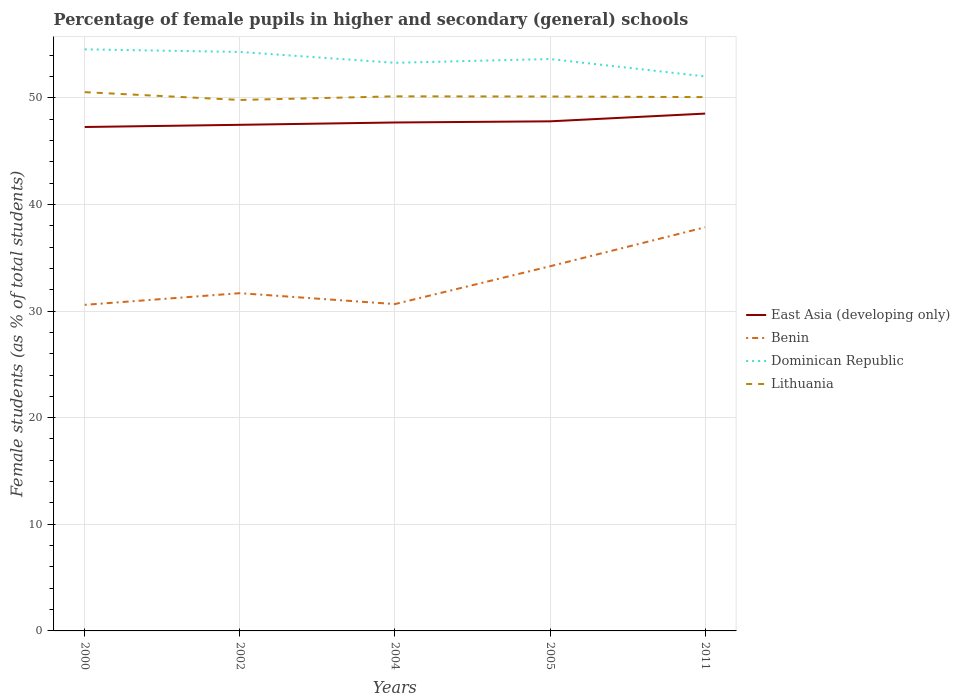Is the number of lines equal to the number of legend labels?
Offer a very short reply. Yes. Across all years, what is the maximum percentage of female pupils in higher and secondary schools in Benin?
Your response must be concise. 30.58. In which year was the percentage of female pupils in higher and secondary schools in Lithuania maximum?
Your answer should be very brief. 2002. What is the total percentage of female pupils in higher and secondary schools in Dominican Republic in the graph?
Provide a short and direct response. 1.63. What is the difference between the highest and the second highest percentage of female pupils in higher and secondary schools in Lithuania?
Your answer should be very brief. 0.73. How many years are there in the graph?
Give a very brief answer. 5. What is the difference between two consecutive major ticks on the Y-axis?
Your answer should be very brief. 10. Are the values on the major ticks of Y-axis written in scientific E-notation?
Offer a terse response. No. Does the graph contain any zero values?
Offer a very short reply. No. Where does the legend appear in the graph?
Provide a short and direct response. Center right. How are the legend labels stacked?
Provide a succinct answer. Vertical. What is the title of the graph?
Provide a short and direct response. Percentage of female pupils in higher and secondary (general) schools. Does "Saudi Arabia" appear as one of the legend labels in the graph?
Offer a terse response. No. What is the label or title of the Y-axis?
Provide a succinct answer. Female students (as % of total students). What is the Female students (as % of total students) of East Asia (developing only) in 2000?
Provide a short and direct response. 47.26. What is the Female students (as % of total students) of Benin in 2000?
Offer a very short reply. 30.58. What is the Female students (as % of total students) in Dominican Republic in 2000?
Your answer should be very brief. 54.54. What is the Female students (as % of total students) in Lithuania in 2000?
Provide a succinct answer. 50.53. What is the Female students (as % of total students) in East Asia (developing only) in 2002?
Give a very brief answer. 47.47. What is the Female students (as % of total students) of Benin in 2002?
Your answer should be compact. 31.67. What is the Female students (as % of total students) of Dominican Republic in 2002?
Ensure brevity in your answer.  54.3. What is the Female students (as % of total students) in Lithuania in 2002?
Offer a very short reply. 49.8. What is the Female students (as % of total students) of East Asia (developing only) in 2004?
Offer a very short reply. 47.68. What is the Female students (as % of total students) of Benin in 2004?
Keep it short and to the point. 30.65. What is the Female students (as % of total students) in Dominican Republic in 2004?
Provide a succinct answer. 53.28. What is the Female students (as % of total students) in Lithuania in 2004?
Your answer should be compact. 50.14. What is the Female students (as % of total students) of East Asia (developing only) in 2005?
Keep it short and to the point. 47.79. What is the Female students (as % of total students) in Benin in 2005?
Provide a short and direct response. 34.2. What is the Female students (as % of total students) of Dominican Republic in 2005?
Offer a terse response. 53.64. What is the Female students (as % of total students) in Lithuania in 2005?
Your response must be concise. 50.12. What is the Female students (as % of total students) in East Asia (developing only) in 2011?
Your answer should be compact. 48.52. What is the Female students (as % of total students) in Benin in 2011?
Give a very brief answer. 37.86. What is the Female students (as % of total students) in Dominican Republic in 2011?
Make the answer very short. 52. What is the Female students (as % of total students) in Lithuania in 2011?
Your response must be concise. 50.06. Across all years, what is the maximum Female students (as % of total students) in East Asia (developing only)?
Provide a succinct answer. 48.52. Across all years, what is the maximum Female students (as % of total students) in Benin?
Provide a short and direct response. 37.86. Across all years, what is the maximum Female students (as % of total students) of Dominican Republic?
Give a very brief answer. 54.54. Across all years, what is the maximum Female students (as % of total students) of Lithuania?
Your answer should be very brief. 50.53. Across all years, what is the minimum Female students (as % of total students) of East Asia (developing only)?
Ensure brevity in your answer.  47.26. Across all years, what is the minimum Female students (as % of total students) of Benin?
Offer a terse response. 30.58. Across all years, what is the minimum Female students (as % of total students) of Dominican Republic?
Ensure brevity in your answer.  52. Across all years, what is the minimum Female students (as % of total students) of Lithuania?
Your response must be concise. 49.8. What is the total Female students (as % of total students) of East Asia (developing only) in the graph?
Offer a very short reply. 238.71. What is the total Female students (as % of total students) of Benin in the graph?
Provide a short and direct response. 164.96. What is the total Female students (as % of total students) of Dominican Republic in the graph?
Your answer should be compact. 267.76. What is the total Female students (as % of total students) in Lithuania in the graph?
Offer a very short reply. 250.64. What is the difference between the Female students (as % of total students) of East Asia (developing only) in 2000 and that in 2002?
Provide a succinct answer. -0.21. What is the difference between the Female students (as % of total students) in Benin in 2000 and that in 2002?
Make the answer very short. -1.09. What is the difference between the Female students (as % of total students) of Dominican Republic in 2000 and that in 2002?
Offer a terse response. 0.24. What is the difference between the Female students (as % of total students) of Lithuania in 2000 and that in 2002?
Make the answer very short. 0.73. What is the difference between the Female students (as % of total students) in East Asia (developing only) in 2000 and that in 2004?
Provide a succinct answer. -0.42. What is the difference between the Female students (as % of total students) of Benin in 2000 and that in 2004?
Give a very brief answer. -0.07. What is the difference between the Female students (as % of total students) in Dominican Republic in 2000 and that in 2004?
Ensure brevity in your answer.  1.26. What is the difference between the Female students (as % of total students) of Lithuania in 2000 and that in 2004?
Offer a terse response. 0.39. What is the difference between the Female students (as % of total students) of East Asia (developing only) in 2000 and that in 2005?
Provide a short and direct response. -0.53. What is the difference between the Female students (as % of total students) in Benin in 2000 and that in 2005?
Keep it short and to the point. -3.62. What is the difference between the Female students (as % of total students) in Dominican Republic in 2000 and that in 2005?
Provide a succinct answer. 0.91. What is the difference between the Female students (as % of total students) in Lithuania in 2000 and that in 2005?
Provide a succinct answer. 0.41. What is the difference between the Female students (as % of total students) of East Asia (developing only) in 2000 and that in 2011?
Ensure brevity in your answer.  -1.26. What is the difference between the Female students (as % of total students) in Benin in 2000 and that in 2011?
Offer a terse response. -7.27. What is the difference between the Female students (as % of total students) of Dominican Republic in 2000 and that in 2011?
Offer a terse response. 2.54. What is the difference between the Female students (as % of total students) in Lithuania in 2000 and that in 2011?
Your response must be concise. 0.46. What is the difference between the Female students (as % of total students) in East Asia (developing only) in 2002 and that in 2004?
Your answer should be very brief. -0.22. What is the difference between the Female students (as % of total students) of Benin in 2002 and that in 2004?
Offer a terse response. 1.02. What is the difference between the Female students (as % of total students) in Dominican Republic in 2002 and that in 2004?
Your answer should be compact. 1.02. What is the difference between the Female students (as % of total students) of Lithuania in 2002 and that in 2004?
Make the answer very short. -0.34. What is the difference between the Female students (as % of total students) in East Asia (developing only) in 2002 and that in 2005?
Keep it short and to the point. -0.33. What is the difference between the Female students (as % of total students) in Benin in 2002 and that in 2005?
Offer a terse response. -2.52. What is the difference between the Female students (as % of total students) in Dominican Republic in 2002 and that in 2005?
Your answer should be compact. 0.66. What is the difference between the Female students (as % of total students) in Lithuania in 2002 and that in 2005?
Your answer should be very brief. -0.32. What is the difference between the Female students (as % of total students) of East Asia (developing only) in 2002 and that in 2011?
Provide a short and direct response. -1.05. What is the difference between the Female students (as % of total students) in Benin in 2002 and that in 2011?
Provide a short and direct response. -6.18. What is the difference between the Female students (as % of total students) of Dominican Republic in 2002 and that in 2011?
Your answer should be compact. 2.3. What is the difference between the Female students (as % of total students) of Lithuania in 2002 and that in 2011?
Ensure brevity in your answer.  -0.27. What is the difference between the Female students (as % of total students) of East Asia (developing only) in 2004 and that in 2005?
Make the answer very short. -0.11. What is the difference between the Female students (as % of total students) of Benin in 2004 and that in 2005?
Offer a very short reply. -3.54. What is the difference between the Female students (as % of total students) of Dominican Republic in 2004 and that in 2005?
Your answer should be very brief. -0.36. What is the difference between the Female students (as % of total students) in Lithuania in 2004 and that in 2005?
Make the answer very short. 0.02. What is the difference between the Female students (as % of total students) of East Asia (developing only) in 2004 and that in 2011?
Offer a very short reply. -0.83. What is the difference between the Female students (as % of total students) of Benin in 2004 and that in 2011?
Your answer should be very brief. -7.2. What is the difference between the Female students (as % of total students) of Dominican Republic in 2004 and that in 2011?
Give a very brief answer. 1.28. What is the difference between the Female students (as % of total students) in Lithuania in 2004 and that in 2011?
Give a very brief answer. 0.07. What is the difference between the Female students (as % of total students) in East Asia (developing only) in 2005 and that in 2011?
Ensure brevity in your answer.  -0.73. What is the difference between the Female students (as % of total students) in Benin in 2005 and that in 2011?
Your answer should be very brief. -3.66. What is the difference between the Female students (as % of total students) of Dominican Republic in 2005 and that in 2011?
Offer a very short reply. 1.63. What is the difference between the Female students (as % of total students) of Lithuania in 2005 and that in 2011?
Your response must be concise. 0.05. What is the difference between the Female students (as % of total students) of East Asia (developing only) in 2000 and the Female students (as % of total students) of Benin in 2002?
Your response must be concise. 15.58. What is the difference between the Female students (as % of total students) in East Asia (developing only) in 2000 and the Female students (as % of total students) in Dominican Republic in 2002?
Your answer should be compact. -7.04. What is the difference between the Female students (as % of total students) of East Asia (developing only) in 2000 and the Female students (as % of total students) of Lithuania in 2002?
Give a very brief answer. -2.54. What is the difference between the Female students (as % of total students) in Benin in 2000 and the Female students (as % of total students) in Dominican Republic in 2002?
Offer a terse response. -23.72. What is the difference between the Female students (as % of total students) of Benin in 2000 and the Female students (as % of total students) of Lithuania in 2002?
Your response must be concise. -19.21. What is the difference between the Female students (as % of total students) in Dominican Republic in 2000 and the Female students (as % of total students) in Lithuania in 2002?
Make the answer very short. 4.75. What is the difference between the Female students (as % of total students) in East Asia (developing only) in 2000 and the Female students (as % of total students) in Benin in 2004?
Ensure brevity in your answer.  16.61. What is the difference between the Female students (as % of total students) of East Asia (developing only) in 2000 and the Female students (as % of total students) of Dominican Republic in 2004?
Your answer should be very brief. -6.02. What is the difference between the Female students (as % of total students) in East Asia (developing only) in 2000 and the Female students (as % of total students) in Lithuania in 2004?
Offer a very short reply. -2.88. What is the difference between the Female students (as % of total students) of Benin in 2000 and the Female students (as % of total students) of Dominican Republic in 2004?
Your answer should be compact. -22.7. What is the difference between the Female students (as % of total students) in Benin in 2000 and the Female students (as % of total students) in Lithuania in 2004?
Offer a very short reply. -19.55. What is the difference between the Female students (as % of total students) of Dominican Republic in 2000 and the Female students (as % of total students) of Lithuania in 2004?
Provide a succinct answer. 4.41. What is the difference between the Female students (as % of total students) in East Asia (developing only) in 2000 and the Female students (as % of total students) in Benin in 2005?
Make the answer very short. 13.06. What is the difference between the Female students (as % of total students) of East Asia (developing only) in 2000 and the Female students (as % of total students) of Dominican Republic in 2005?
Your answer should be compact. -6.38. What is the difference between the Female students (as % of total students) in East Asia (developing only) in 2000 and the Female students (as % of total students) in Lithuania in 2005?
Keep it short and to the point. -2.86. What is the difference between the Female students (as % of total students) in Benin in 2000 and the Female students (as % of total students) in Dominican Republic in 2005?
Ensure brevity in your answer.  -23.05. What is the difference between the Female students (as % of total students) in Benin in 2000 and the Female students (as % of total students) in Lithuania in 2005?
Make the answer very short. -19.54. What is the difference between the Female students (as % of total students) in Dominican Republic in 2000 and the Female students (as % of total students) in Lithuania in 2005?
Keep it short and to the point. 4.42. What is the difference between the Female students (as % of total students) in East Asia (developing only) in 2000 and the Female students (as % of total students) in Benin in 2011?
Offer a terse response. 9.4. What is the difference between the Female students (as % of total students) of East Asia (developing only) in 2000 and the Female students (as % of total students) of Dominican Republic in 2011?
Provide a short and direct response. -4.74. What is the difference between the Female students (as % of total students) in East Asia (developing only) in 2000 and the Female students (as % of total students) in Lithuania in 2011?
Offer a very short reply. -2.81. What is the difference between the Female students (as % of total students) in Benin in 2000 and the Female students (as % of total students) in Dominican Republic in 2011?
Give a very brief answer. -21.42. What is the difference between the Female students (as % of total students) of Benin in 2000 and the Female students (as % of total students) of Lithuania in 2011?
Your answer should be compact. -19.48. What is the difference between the Female students (as % of total students) of Dominican Republic in 2000 and the Female students (as % of total students) of Lithuania in 2011?
Your response must be concise. 4.48. What is the difference between the Female students (as % of total students) in East Asia (developing only) in 2002 and the Female students (as % of total students) in Benin in 2004?
Make the answer very short. 16.81. What is the difference between the Female students (as % of total students) of East Asia (developing only) in 2002 and the Female students (as % of total students) of Dominican Republic in 2004?
Provide a succinct answer. -5.81. What is the difference between the Female students (as % of total students) in East Asia (developing only) in 2002 and the Female students (as % of total students) in Lithuania in 2004?
Your response must be concise. -2.67. What is the difference between the Female students (as % of total students) of Benin in 2002 and the Female students (as % of total students) of Dominican Republic in 2004?
Your answer should be compact. -21.61. What is the difference between the Female students (as % of total students) of Benin in 2002 and the Female students (as % of total students) of Lithuania in 2004?
Provide a succinct answer. -18.46. What is the difference between the Female students (as % of total students) of Dominican Republic in 2002 and the Female students (as % of total students) of Lithuania in 2004?
Provide a short and direct response. 4.16. What is the difference between the Female students (as % of total students) of East Asia (developing only) in 2002 and the Female students (as % of total students) of Benin in 2005?
Keep it short and to the point. 13.27. What is the difference between the Female students (as % of total students) of East Asia (developing only) in 2002 and the Female students (as % of total students) of Dominican Republic in 2005?
Your answer should be compact. -6.17. What is the difference between the Female students (as % of total students) of East Asia (developing only) in 2002 and the Female students (as % of total students) of Lithuania in 2005?
Keep it short and to the point. -2.65. What is the difference between the Female students (as % of total students) of Benin in 2002 and the Female students (as % of total students) of Dominican Republic in 2005?
Your answer should be very brief. -21.96. What is the difference between the Female students (as % of total students) of Benin in 2002 and the Female students (as % of total students) of Lithuania in 2005?
Make the answer very short. -18.44. What is the difference between the Female students (as % of total students) of Dominican Republic in 2002 and the Female students (as % of total students) of Lithuania in 2005?
Your answer should be very brief. 4.18. What is the difference between the Female students (as % of total students) in East Asia (developing only) in 2002 and the Female students (as % of total students) in Benin in 2011?
Ensure brevity in your answer.  9.61. What is the difference between the Female students (as % of total students) of East Asia (developing only) in 2002 and the Female students (as % of total students) of Dominican Republic in 2011?
Provide a short and direct response. -4.54. What is the difference between the Female students (as % of total students) in East Asia (developing only) in 2002 and the Female students (as % of total students) in Lithuania in 2011?
Ensure brevity in your answer.  -2.6. What is the difference between the Female students (as % of total students) in Benin in 2002 and the Female students (as % of total students) in Dominican Republic in 2011?
Make the answer very short. -20.33. What is the difference between the Female students (as % of total students) of Benin in 2002 and the Female students (as % of total students) of Lithuania in 2011?
Your answer should be compact. -18.39. What is the difference between the Female students (as % of total students) in Dominican Republic in 2002 and the Female students (as % of total students) in Lithuania in 2011?
Provide a short and direct response. 4.23. What is the difference between the Female students (as % of total students) of East Asia (developing only) in 2004 and the Female students (as % of total students) of Benin in 2005?
Offer a terse response. 13.48. What is the difference between the Female students (as % of total students) in East Asia (developing only) in 2004 and the Female students (as % of total students) in Dominican Republic in 2005?
Offer a very short reply. -5.95. What is the difference between the Female students (as % of total students) in East Asia (developing only) in 2004 and the Female students (as % of total students) in Lithuania in 2005?
Offer a terse response. -2.44. What is the difference between the Female students (as % of total students) of Benin in 2004 and the Female students (as % of total students) of Dominican Republic in 2005?
Give a very brief answer. -22.98. What is the difference between the Female students (as % of total students) of Benin in 2004 and the Female students (as % of total students) of Lithuania in 2005?
Your answer should be compact. -19.47. What is the difference between the Female students (as % of total students) in Dominican Republic in 2004 and the Female students (as % of total students) in Lithuania in 2005?
Offer a very short reply. 3.16. What is the difference between the Female students (as % of total students) in East Asia (developing only) in 2004 and the Female students (as % of total students) in Benin in 2011?
Your answer should be very brief. 9.83. What is the difference between the Female students (as % of total students) of East Asia (developing only) in 2004 and the Female students (as % of total students) of Dominican Republic in 2011?
Keep it short and to the point. -4.32. What is the difference between the Female students (as % of total students) in East Asia (developing only) in 2004 and the Female students (as % of total students) in Lithuania in 2011?
Provide a short and direct response. -2.38. What is the difference between the Female students (as % of total students) in Benin in 2004 and the Female students (as % of total students) in Dominican Republic in 2011?
Offer a very short reply. -21.35. What is the difference between the Female students (as % of total students) of Benin in 2004 and the Female students (as % of total students) of Lithuania in 2011?
Make the answer very short. -19.41. What is the difference between the Female students (as % of total students) of Dominican Republic in 2004 and the Female students (as % of total students) of Lithuania in 2011?
Give a very brief answer. 3.22. What is the difference between the Female students (as % of total students) of East Asia (developing only) in 2005 and the Female students (as % of total students) of Benin in 2011?
Give a very brief answer. 9.94. What is the difference between the Female students (as % of total students) in East Asia (developing only) in 2005 and the Female students (as % of total students) in Dominican Republic in 2011?
Keep it short and to the point. -4.21. What is the difference between the Female students (as % of total students) in East Asia (developing only) in 2005 and the Female students (as % of total students) in Lithuania in 2011?
Your answer should be compact. -2.27. What is the difference between the Female students (as % of total students) of Benin in 2005 and the Female students (as % of total students) of Dominican Republic in 2011?
Provide a succinct answer. -17.8. What is the difference between the Female students (as % of total students) in Benin in 2005 and the Female students (as % of total students) in Lithuania in 2011?
Your response must be concise. -15.87. What is the difference between the Female students (as % of total students) of Dominican Republic in 2005 and the Female students (as % of total students) of Lithuania in 2011?
Keep it short and to the point. 3.57. What is the average Female students (as % of total students) of East Asia (developing only) per year?
Ensure brevity in your answer.  47.74. What is the average Female students (as % of total students) of Benin per year?
Keep it short and to the point. 32.99. What is the average Female students (as % of total students) of Dominican Republic per year?
Your answer should be very brief. 53.55. What is the average Female students (as % of total students) in Lithuania per year?
Ensure brevity in your answer.  50.13. In the year 2000, what is the difference between the Female students (as % of total students) of East Asia (developing only) and Female students (as % of total students) of Benin?
Your answer should be very brief. 16.68. In the year 2000, what is the difference between the Female students (as % of total students) of East Asia (developing only) and Female students (as % of total students) of Dominican Republic?
Your response must be concise. -7.28. In the year 2000, what is the difference between the Female students (as % of total students) in East Asia (developing only) and Female students (as % of total students) in Lithuania?
Keep it short and to the point. -3.27. In the year 2000, what is the difference between the Female students (as % of total students) in Benin and Female students (as % of total students) in Dominican Republic?
Your answer should be very brief. -23.96. In the year 2000, what is the difference between the Female students (as % of total students) in Benin and Female students (as % of total students) in Lithuania?
Give a very brief answer. -19.95. In the year 2000, what is the difference between the Female students (as % of total students) of Dominican Republic and Female students (as % of total students) of Lithuania?
Make the answer very short. 4.01. In the year 2002, what is the difference between the Female students (as % of total students) in East Asia (developing only) and Female students (as % of total students) in Benin?
Give a very brief answer. 15.79. In the year 2002, what is the difference between the Female students (as % of total students) of East Asia (developing only) and Female students (as % of total students) of Dominican Republic?
Give a very brief answer. -6.83. In the year 2002, what is the difference between the Female students (as % of total students) of East Asia (developing only) and Female students (as % of total students) of Lithuania?
Offer a terse response. -2.33. In the year 2002, what is the difference between the Female students (as % of total students) in Benin and Female students (as % of total students) in Dominican Republic?
Ensure brevity in your answer.  -22.62. In the year 2002, what is the difference between the Female students (as % of total students) in Benin and Female students (as % of total students) in Lithuania?
Ensure brevity in your answer.  -18.12. In the year 2002, what is the difference between the Female students (as % of total students) in Dominican Republic and Female students (as % of total students) in Lithuania?
Your answer should be compact. 4.5. In the year 2004, what is the difference between the Female students (as % of total students) in East Asia (developing only) and Female students (as % of total students) in Benin?
Give a very brief answer. 17.03. In the year 2004, what is the difference between the Female students (as % of total students) in East Asia (developing only) and Female students (as % of total students) in Dominican Republic?
Your answer should be very brief. -5.6. In the year 2004, what is the difference between the Female students (as % of total students) in East Asia (developing only) and Female students (as % of total students) in Lithuania?
Provide a succinct answer. -2.45. In the year 2004, what is the difference between the Female students (as % of total students) of Benin and Female students (as % of total students) of Dominican Republic?
Your response must be concise. -22.63. In the year 2004, what is the difference between the Female students (as % of total students) of Benin and Female students (as % of total students) of Lithuania?
Keep it short and to the point. -19.48. In the year 2004, what is the difference between the Female students (as % of total students) of Dominican Republic and Female students (as % of total students) of Lithuania?
Provide a short and direct response. 3.14. In the year 2005, what is the difference between the Female students (as % of total students) of East Asia (developing only) and Female students (as % of total students) of Benin?
Provide a short and direct response. 13.59. In the year 2005, what is the difference between the Female students (as % of total students) of East Asia (developing only) and Female students (as % of total students) of Dominican Republic?
Provide a short and direct response. -5.84. In the year 2005, what is the difference between the Female students (as % of total students) of East Asia (developing only) and Female students (as % of total students) of Lithuania?
Your answer should be compact. -2.33. In the year 2005, what is the difference between the Female students (as % of total students) in Benin and Female students (as % of total students) in Dominican Republic?
Offer a terse response. -19.44. In the year 2005, what is the difference between the Female students (as % of total students) in Benin and Female students (as % of total students) in Lithuania?
Keep it short and to the point. -15.92. In the year 2005, what is the difference between the Female students (as % of total students) of Dominican Republic and Female students (as % of total students) of Lithuania?
Your answer should be compact. 3.52. In the year 2011, what is the difference between the Female students (as % of total students) of East Asia (developing only) and Female students (as % of total students) of Benin?
Your answer should be very brief. 10.66. In the year 2011, what is the difference between the Female students (as % of total students) of East Asia (developing only) and Female students (as % of total students) of Dominican Republic?
Keep it short and to the point. -3.49. In the year 2011, what is the difference between the Female students (as % of total students) of East Asia (developing only) and Female students (as % of total students) of Lithuania?
Keep it short and to the point. -1.55. In the year 2011, what is the difference between the Female students (as % of total students) in Benin and Female students (as % of total students) in Dominican Republic?
Make the answer very short. -14.15. In the year 2011, what is the difference between the Female students (as % of total students) of Benin and Female students (as % of total students) of Lithuania?
Offer a terse response. -12.21. In the year 2011, what is the difference between the Female students (as % of total students) of Dominican Republic and Female students (as % of total students) of Lithuania?
Ensure brevity in your answer.  1.94. What is the ratio of the Female students (as % of total students) in Benin in 2000 to that in 2002?
Offer a terse response. 0.97. What is the ratio of the Female students (as % of total students) in Dominican Republic in 2000 to that in 2002?
Keep it short and to the point. 1. What is the ratio of the Female students (as % of total students) in Lithuania in 2000 to that in 2002?
Your response must be concise. 1.01. What is the ratio of the Female students (as % of total students) of East Asia (developing only) in 2000 to that in 2004?
Provide a short and direct response. 0.99. What is the ratio of the Female students (as % of total students) of Dominican Republic in 2000 to that in 2004?
Ensure brevity in your answer.  1.02. What is the ratio of the Female students (as % of total students) in East Asia (developing only) in 2000 to that in 2005?
Make the answer very short. 0.99. What is the ratio of the Female students (as % of total students) of Benin in 2000 to that in 2005?
Your answer should be compact. 0.89. What is the ratio of the Female students (as % of total students) in Dominican Republic in 2000 to that in 2005?
Keep it short and to the point. 1.02. What is the ratio of the Female students (as % of total students) in Lithuania in 2000 to that in 2005?
Your answer should be very brief. 1.01. What is the ratio of the Female students (as % of total students) in East Asia (developing only) in 2000 to that in 2011?
Make the answer very short. 0.97. What is the ratio of the Female students (as % of total students) in Benin in 2000 to that in 2011?
Ensure brevity in your answer.  0.81. What is the ratio of the Female students (as % of total students) in Dominican Republic in 2000 to that in 2011?
Ensure brevity in your answer.  1.05. What is the ratio of the Female students (as % of total students) of Lithuania in 2000 to that in 2011?
Offer a very short reply. 1.01. What is the ratio of the Female students (as % of total students) of Benin in 2002 to that in 2004?
Provide a short and direct response. 1.03. What is the ratio of the Female students (as % of total students) of Dominican Republic in 2002 to that in 2004?
Provide a short and direct response. 1.02. What is the ratio of the Female students (as % of total students) in East Asia (developing only) in 2002 to that in 2005?
Your answer should be very brief. 0.99. What is the ratio of the Female students (as % of total students) in Benin in 2002 to that in 2005?
Keep it short and to the point. 0.93. What is the ratio of the Female students (as % of total students) of Dominican Republic in 2002 to that in 2005?
Offer a terse response. 1.01. What is the ratio of the Female students (as % of total students) of East Asia (developing only) in 2002 to that in 2011?
Your answer should be compact. 0.98. What is the ratio of the Female students (as % of total students) of Benin in 2002 to that in 2011?
Offer a very short reply. 0.84. What is the ratio of the Female students (as % of total students) in Dominican Republic in 2002 to that in 2011?
Your answer should be very brief. 1.04. What is the ratio of the Female students (as % of total students) of East Asia (developing only) in 2004 to that in 2005?
Your response must be concise. 1. What is the ratio of the Female students (as % of total students) of Benin in 2004 to that in 2005?
Offer a terse response. 0.9. What is the ratio of the Female students (as % of total students) in Dominican Republic in 2004 to that in 2005?
Your answer should be compact. 0.99. What is the ratio of the Female students (as % of total students) in Lithuania in 2004 to that in 2005?
Make the answer very short. 1. What is the ratio of the Female students (as % of total students) of East Asia (developing only) in 2004 to that in 2011?
Offer a very short reply. 0.98. What is the ratio of the Female students (as % of total students) of Benin in 2004 to that in 2011?
Provide a short and direct response. 0.81. What is the ratio of the Female students (as % of total students) of Dominican Republic in 2004 to that in 2011?
Give a very brief answer. 1.02. What is the ratio of the Female students (as % of total students) in East Asia (developing only) in 2005 to that in 2011?
Your answer should be very brief. 0.98. What is the ratio of the Female students (as % of total students) of Benin in 2005 to that in 2011?
Offer a very short reply. 0.9. What is the ratio of the Female students (as % of total students) of Dominican Republic in 2005 to that in 2011?
Offer a terse response. 1.03. What is the ratio of the Female students (as % of total students) of Lithuania in 2005 to that in 2011?
Your answer should be compact. 1. What is the difference between the highest and the second highest Female students (as % of total students) of East Asia (developing only)?
Your response must be concise. 0.73. What is the difference between the highest and the second highest Female students (as % of total students) of Benin?
Your response must be concise. 3.66. What is the difference between the highest and the second highest Female students (as % of total students) in Dominican Republic?
Provide a succinct answer. 0.24. What is the difference between the highest and the second highest Female students (as % of total students) in Lithuania?
Your answer should be very brief. 0.39. What is the difference between the highest and the lowest Female students (as % of total students) of East Asia (developing only)?
Provide a succinct answer. 1.26. What is the difference between the highest and the lowest Female students (as % of total students) of Benin?
Give a very brief answer. 7.27. What is the difference between the highest and the lowest Female students (as % of total students) of Dominican Republic?
Your answer should be compact. 2.54. What is the difference between the highest and the lowest Female students (as % of total students) of Lithuania?
Your answer should be compact. 0.73. 